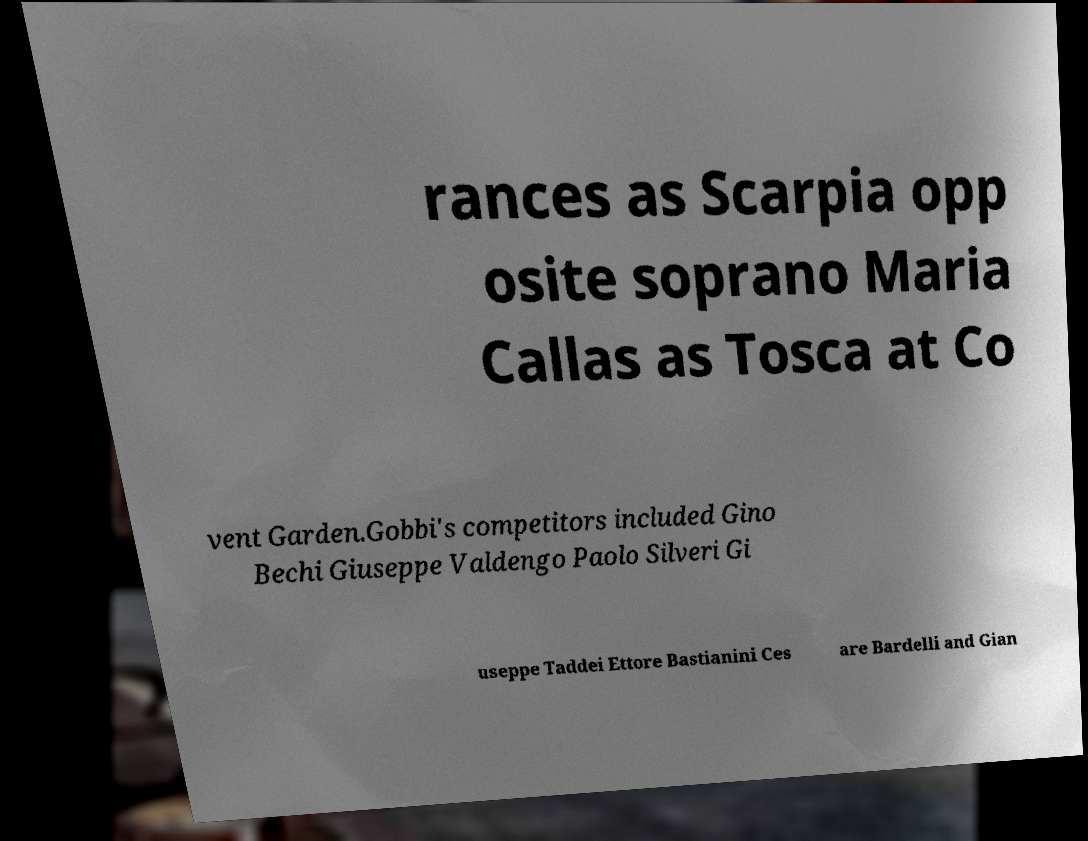Please identify and transcribe the text found in this image. rances as Scarpia opp osite soprano Maria Callas as Tosca at Co vent Garden.Gobbi's competitors included Gino Bechi Giuseppe Valdengo Paolo Silveri Gi useppe Taddei Ettore Bastianini Ces are Bardelli and Gian 